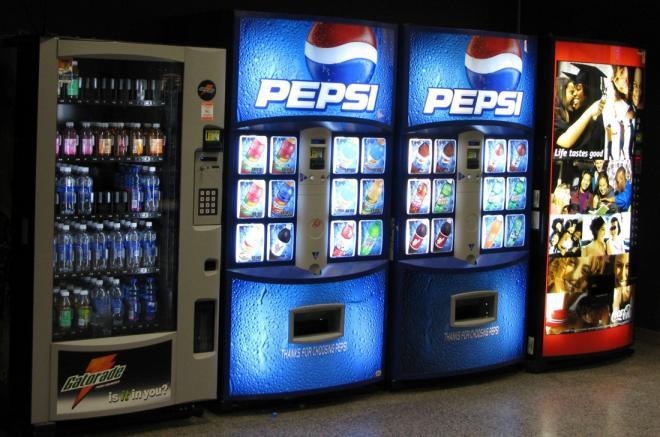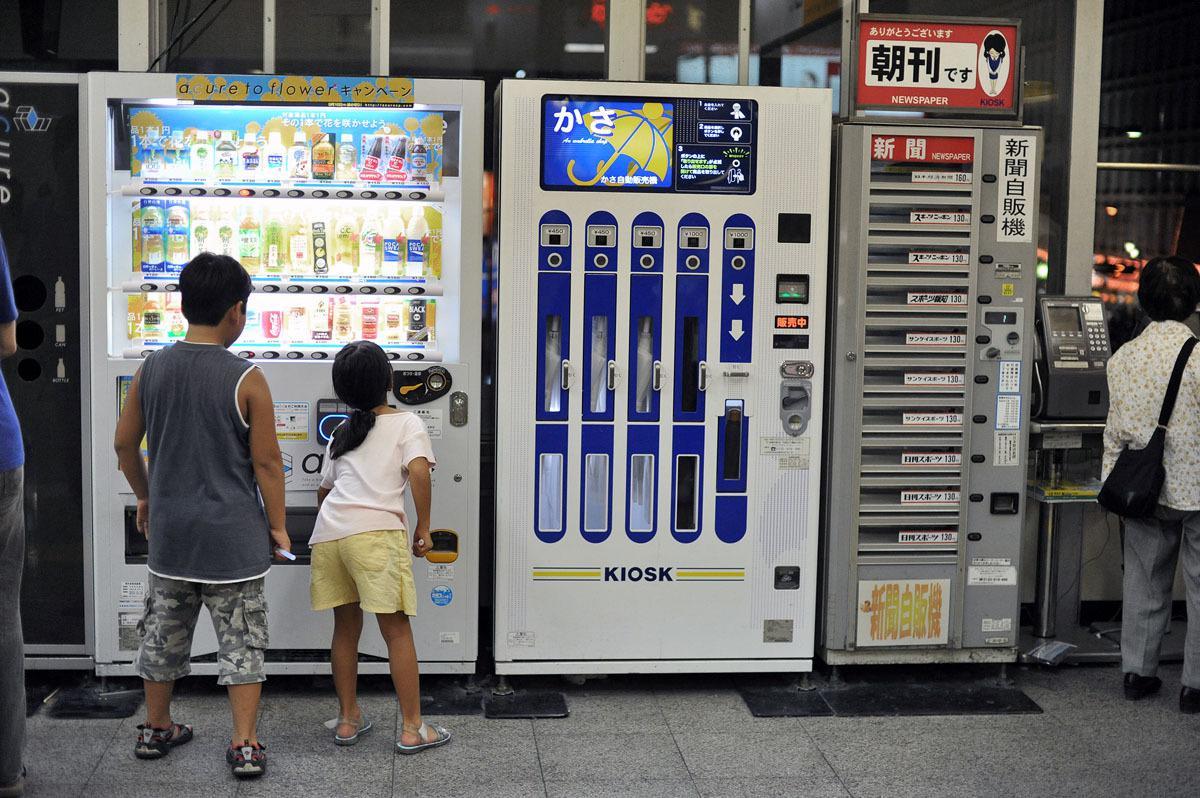The first image is the image on the left, the second image is the image on the right. For the images displayed, is the sentence "There is at least one vending machine with the Pepsi logo on it." factually correct? Answer yes or no. Yes. 